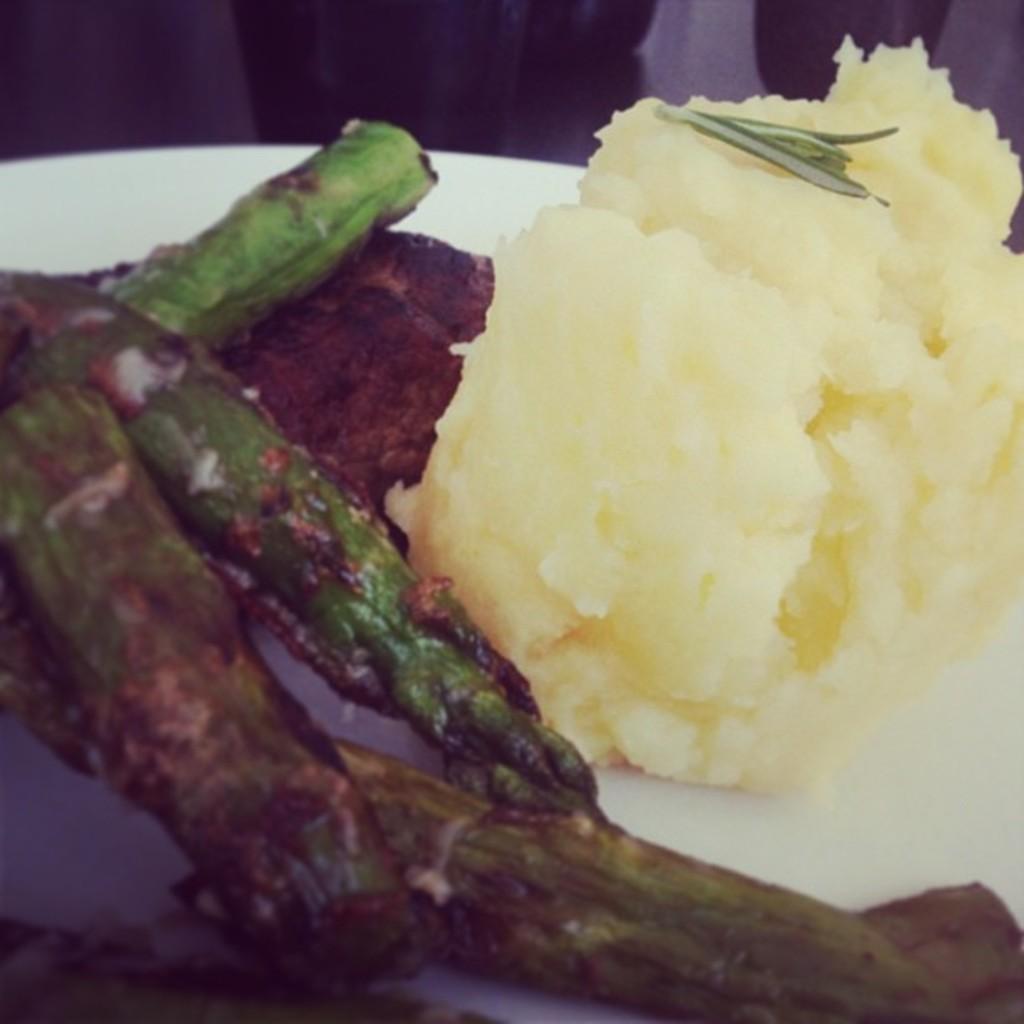Describe this image in one or two sentences. These are the food items in a white color plate. 